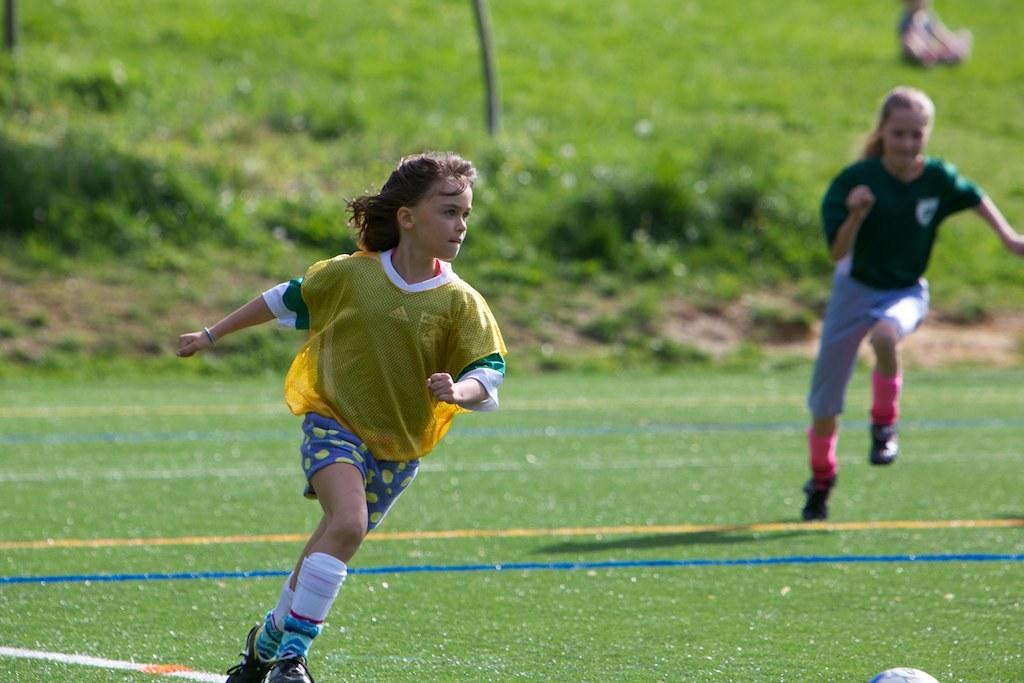What activity are the people in the image engaged in? The people in the image are playing a game. What object is at the bottom of the image? There is a ball at the bottom of the image. What type of terrain is visible in the background of the image? There is grass in the background of the image. How many pies are being used in the game in the image? There is no mention of pies in the image; the game being played does not involve pies. 